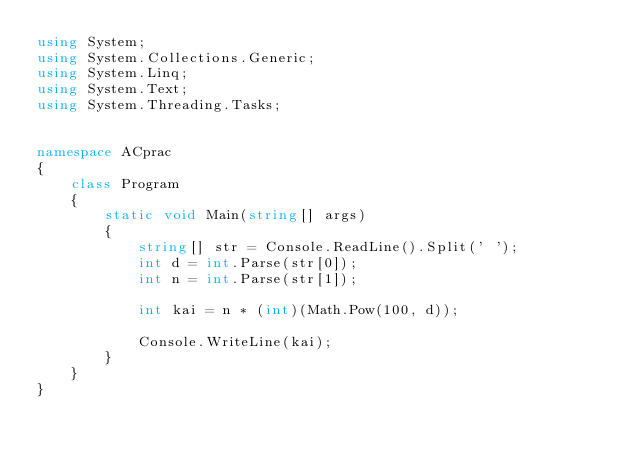<code> <loc_0><loc_0><loc_500><loc_500><_C#_>using System;
using System.Collections.Generic;
using System.Linq;
using System.Text;
using System.Threading.Tasks;


namespace ACprac
{
    class Program
    {
        static void Main(string[] args)
        {
            string[] str = Console.ReadLine().Split(' ');
            int d = int.Parse(str[0]);
            int n = int.Parse(str[1]);

            int kai = n * (int)(Math.Pow(100, d));

            Console.WriteLine(kai);
        }
    }
}
</code> 